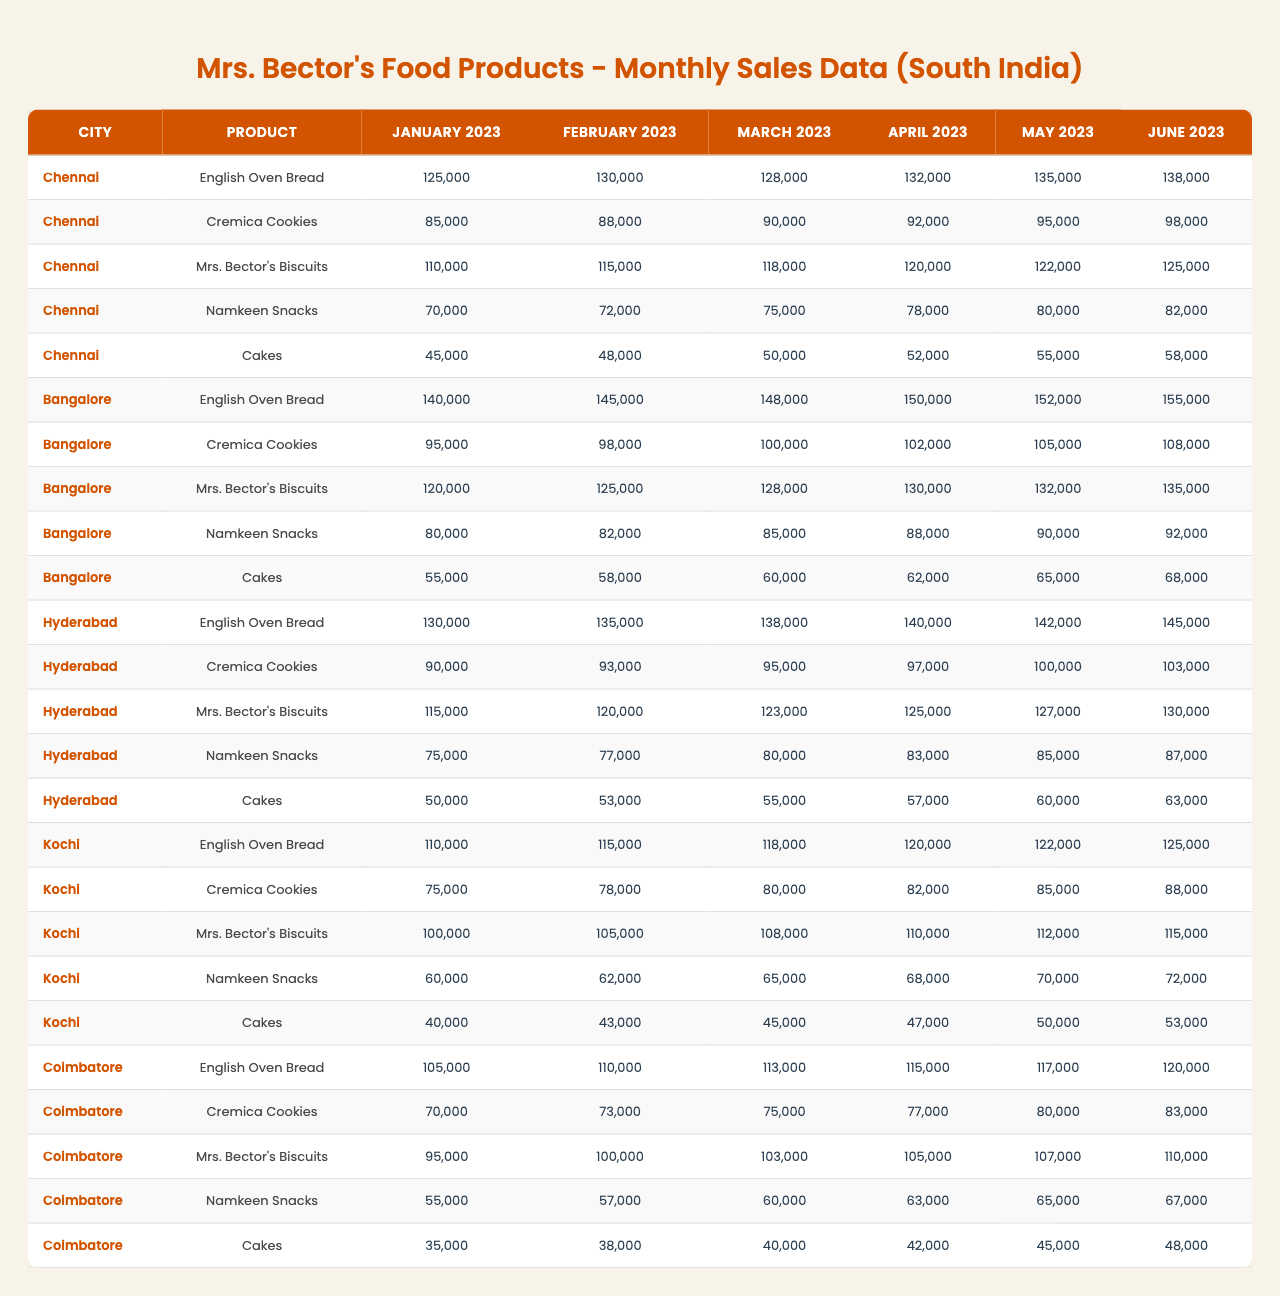What was the total sale of Mrs. Bector's Biscuits in Chennai for May 2023? The sales value for Mrs. Bector's Biscuits in Chennai for May 2023 is 122,000.
Answer: 122000 Which city had the highest sales for Cakes in June 2023? Looking at the sales data for Cakes in June 2023, Bangalore had the highest sales at 68,000 compared to other cities.
Answer: Bangalore What is the sales difference of Namkeen Snacks between March 2023 and April 2023 in Hyderabad? The sales for Namkeen Snacks in Hyderabad for March 2023 is 80,000 and for April 2023 is 83,000. The difference is calculated as 83,000 - 80,000 = 3,000.
Answer: 3000 What was the average monthly sales for English Oven Bread in Coimbatore over the six months? The sales data for English Oven Bread in Coimbatore is [105000, 110000, 113000, 115000, 117000, 120000]. The sum is 690000 and there are 6 months, so the average is 690000/6 = 115000.
Answer: 115000 Did Chennai have the lowest sales for Cremica Cookies in April 2023 among the cities? Comparing the sales data for Cremica Cookies in April 2023: Chennai had 92,000, Bangalore had 102,000, Hyderabad had 97,000, Kochi had 82,000, and Coimbatore had 77,000. The lowest is Coimbatore, so the statement is false.
Answer: No What is the total sales of Namkeen Snacks in Kochi across all months? The sales figures for Namkeen Snacks in Kochi are [60000, 62000, 65000, 68000, 70000, 72000]. Summing these values gives 3,590,000 (60,000 + 62,000 + 65,000 + 68,000 + 70,000 + 72,000 = 3,590,000).
Answer: 359000 Which product consistently showed an increase in sales over the six months in Hyderabad? Analyzing the sales data for different products in Hyderabad: English Oven Bread, Cremica Cookies, Mrs. Bector's Biscuits, Namkeen Snacks, and Cakes show consistent increases. However, Namkeen Snacks also shows a steady increase which can be confirmed with all monthly values rising.
Answer: Yes What was the highest monthly sales figure recorded for Cakes across all cities in January 2023? The monthly sales figures for Cakes in January 2023 across cities are: Chennai - 45,000, Bangalore - 55,000, Hyderabad - 50,000, Kochi - 40,000, and Coimbatore - 35,000. The highest among these is Bangalore's 55,000.
Answer: 55000 How much did sales of Cremica Cookies in Bangalore increase from January to May 2023? The sales figures for Cremica Cookies in Bangalore from January to May 2023 are as follows: January - 95,000, May - 105,000. The increase is 105,000 - 95,000 = 10,000.
Answer: 10000 Which city's sales of English Oven Bread were consistently higher than those of Hyderabad during the first quarter (January to March 2023)? For the first quarter (January to March 2023), the sales figures are: Chennai - 125,000, 130,000, 128,000; Bangalore - 140,000, 145,000, 148,000; and Coimbatore - 105,000, 110,000, 113,000. Only Bangalore had sales consistently higher than Hyderabad's 130,000 at the highest point in this quarter.
Answer: Bangalore 